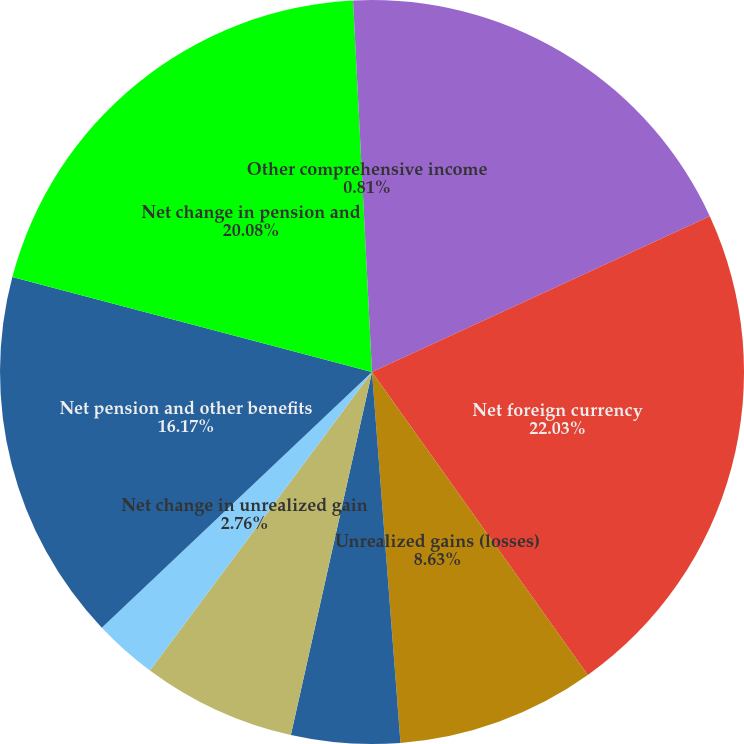<chart> <loc_0><loc_0><loc_500><loc_500><pie_chart><fcel>Translation adjustment arising<fcel>Net foreign currency<fcel>Unrealized gains (losses)<fcel>Reclassification adjustments<fcel>Net gain (loss) on derivatives<fcel>Net change in unrealized gain<fcel>Net pension and other benefits<fcel>Net change in pension and<fcel>Other comprehensive income<nl><fcel>18.12%<fcel>22.03%<fcel>8.63%<fcel>4.72%<fcel>6.68%<fcel>2.76%<fcel>16.17%<fcel>20.08%<fcel>0.81%<nl></chart> 